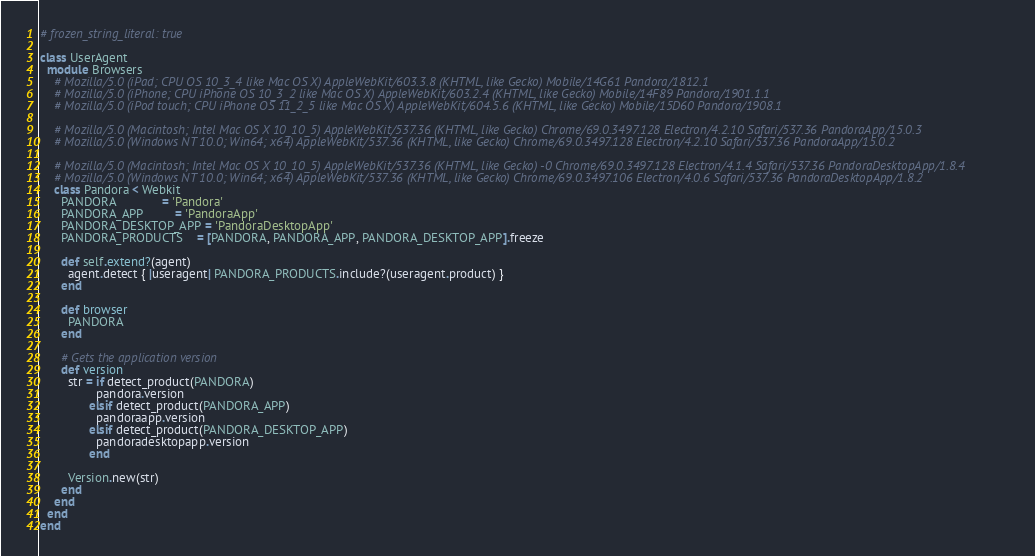Convert code to text. <code><loc_0><loc_0><loc_500><loc_500><_Ruby_># frozen_string_literal: true

class UserAgent
  module Browsers
    # Mozilla/5.0 (iPad; CPU OS 10_3_4 like Mac OS X) AppleWebKit/603.3.8 (KHTML, like Gecko) Mobile/14G61 Pandora/1812.1
    # Mozilla/5.0 (iPhone; CPU iPhone OS 10_3_2 like Mac OS X) AppleWebKit/603.2.4 (KHTML, like Gecko) Mobile/14F89 Pandora/1901.1.1
    # Mozilla/5.0 (iPod touch; CPU iPhone OS 11_2_5 like Mac OS X) AppleWebKit/604.5.6 (KHTML, like Gecko) Mobile/15D60 Pandora/1908.1

    # Mozilla/5.0 (Macintosh; Intel Mac OS X 10_10_5) AppleWebKit/537.36 (KHTML, like Gecko) Chrome/69.0.3497.128 Electron/4.2.10 Safari/537.36 PandoraApp/15.0.3
    # Mozilla/5.0 (Windows NT 10.0; Win64; x64) AppleWebKit/537.36 (KHTML, like Gecko) Chrome/69.0.3497.128 Electron/4.2.10 Safari/537.36 PandoraApp/15.0.2

    # Mozilla/5.0 (Macintosh; Intel Mac OS X 10_10_5) AppleWebKit/537.36 (KHTML, like Gecko) -0 Chrome/69.0.3497.128 Electron/4.1.4 Safari/537.36 PandoraDesktopApp/1.8.4
    # Mozilla/5.0 (Windows NT 10.0; Win64; x64) AppleWebKit/537.36 (KHTML, like Gecko) Chrome/69.0.3497.106 Electron/4.0.6 Safari/537.36 PandoraDesktopApp/1.8.2
    class Pandora < Webkit
      PANDORA             = 'Pandora'
      PANDORA_APP         = 'PandoraApp'
      PANDORA_DESKTOP_APP = 'PandoraDesktopApp'
      PANDORA_PRODUCTS    = [PANDORA, PANDORA_APP, PANDORA_DESKTOP_APP].freeze

      def self.extend?(agent)
        agent.detect { |useragent| PANDORA_PRODUCTS.include?(useragent.product) }
      end

      def browser
        PANDORA
      end

      # Gets the application version
      def version
        str = if detect_product(PANDORA)
                pandora.version
              elsif detect_product(PANDORA_APP)
                pandoraapp.version
              elsif detect_product(PANDORA_DESKTOP_APP)
                pandoradesktopapp.version
              end

        Version.new(str)
      end
    end
  end
end
</code> 